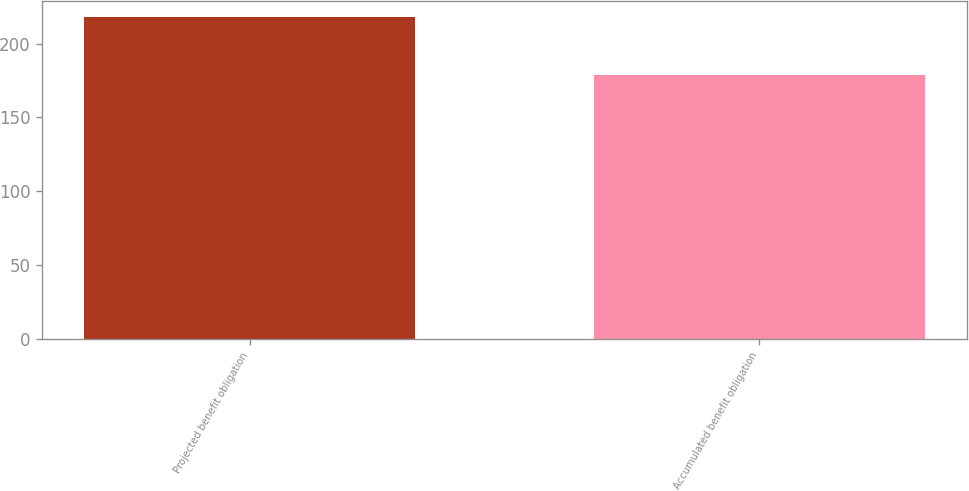<chart> <loc_0><loc_0><loc_500><loc_500><bar_chart><fcel>Projected benefit obligation<fcel>Accumulated benefit obligation<nl><fcel>218<fcel>179<nl></chart> 